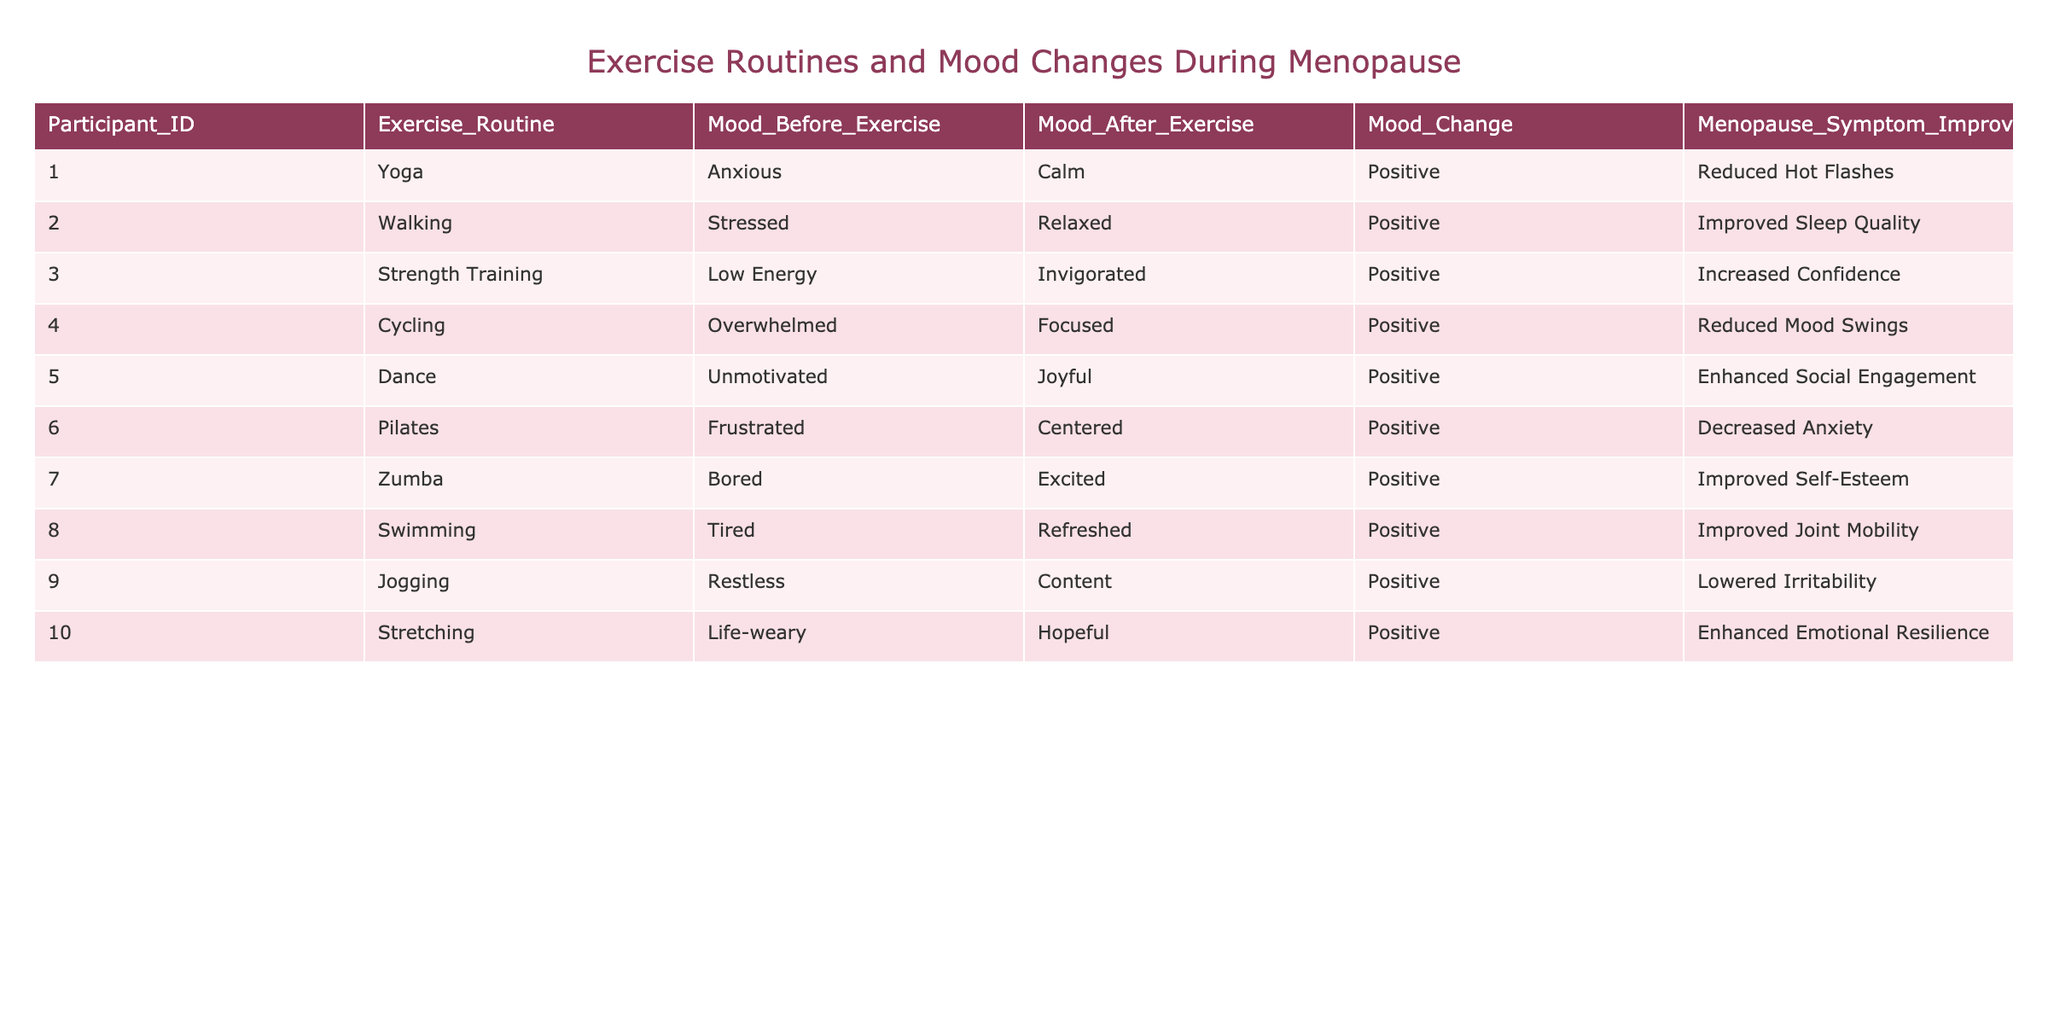What exercise routine was associated with the highest mood change? Looking at the "Mood Change" column, all values are positive. Therefore, we consider other aspects; since every participant improved their mood after exercising, the specific "Mood After Exercise" column and types of exercise can also indicate effectiveness. However, all show positive change with no distinct highest value indicated, so we note that they all resulted in a positive shift.
Answer: None stand out distinctly Which exercise routine led to the improvement of sleep quality? By scanning the "Menopause Symptom Improvement" column, I find that "Walking" is linked to "Improved Sleep Quality."
Answer: Walking Is there any exercise routine that resulted in reduced anxiety levels? In the "Menopause Symptom Improvement" column, "Pilates" is noted for decreasing anxiety, which shows that it directly tackles symptoms related to anxiety.
Answer: Yes, Pilates What was the mood change for participants doing Dance? Referring to the "Mood Change" column for participant 5, the mood shifted from "Unmotivated" to "Joyful," indicating a positive change.
Answer: Positive How many exercise routines listed resulted in increased self-esteem? Reviewing the table, only "Zumba" is noted to improve self-esteem in the "Menopause Symptom Improvement" column, meaning there's just one.
Answer: One What average mood change was reported for the strength training routine? The "Mood Change" column shows it was positive, but since there's only one participant (ID 3) for this routine, the average is also positive as it is the only value available.
Answer: Positive Is there a relationship between Yoga and anxiety reduction in this table? The table indicates that Yoga led to a "Calm" mood after exercise and it was associated with "Reduced Hot Flashes," but it does not specifically address anxiety. Thus, while it may help, we can't definitively state its effect on anxiety reduction.
Answer: Cannot conclude directly Which two exercise routines resulted in participants feeling more focused? By reviewing the "Mood After Exercise" column, "Cycling" changed the mood to "Focused," and "Stretching" led to "Hopeful," but only Cycling is specifically noted for focus improvement.
Answer: Cycling What is the total number of participants who felt invigorated after their exercise? Only participant 3 reported feeling "Invigorated" after Strength Training.
Answer: One participant Based on this data, which exercise routine is best for enhancing social engagement? The "Menopause Symptom Improvement" column states that "Dance" results in "Enhanced Social Engagement," suggesting it is the most beneficial for this aspect.
Answer: Dance 